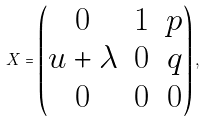Convert formula to latex. <formula><loc_0><loc_0><loc_500><loc_500>X = \begin{pmatrix} 0 & 1 & p \\ u + \lambda & 0 & q \\ 0 & 0 & 0 \end{pmatrix} ,</formula> 